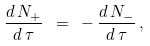<formula> <loc_0><loc_0><loc_500><loc_500>\frac { d \, N _ { + } } { d \, \tau } \ = \ - \, \frac { d \, N _ { - } } { d \, \tau } \, ,</formula> 